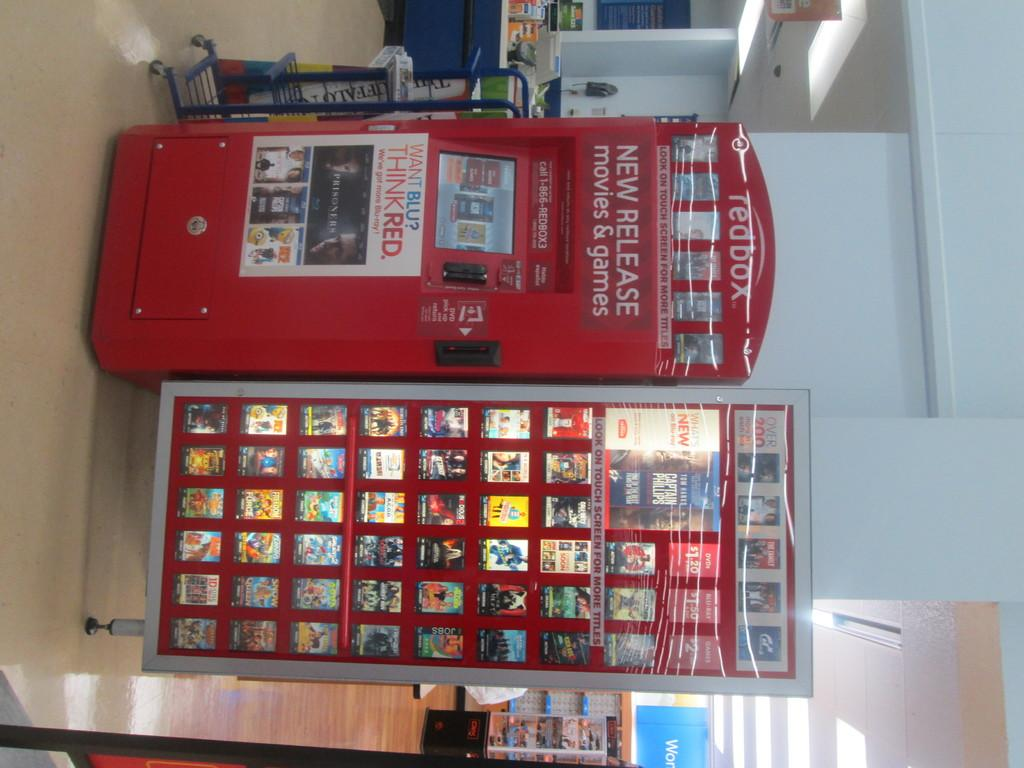<image>
Relay a brief, clear account of the picture shown. redbox machine inside of store with new releases 